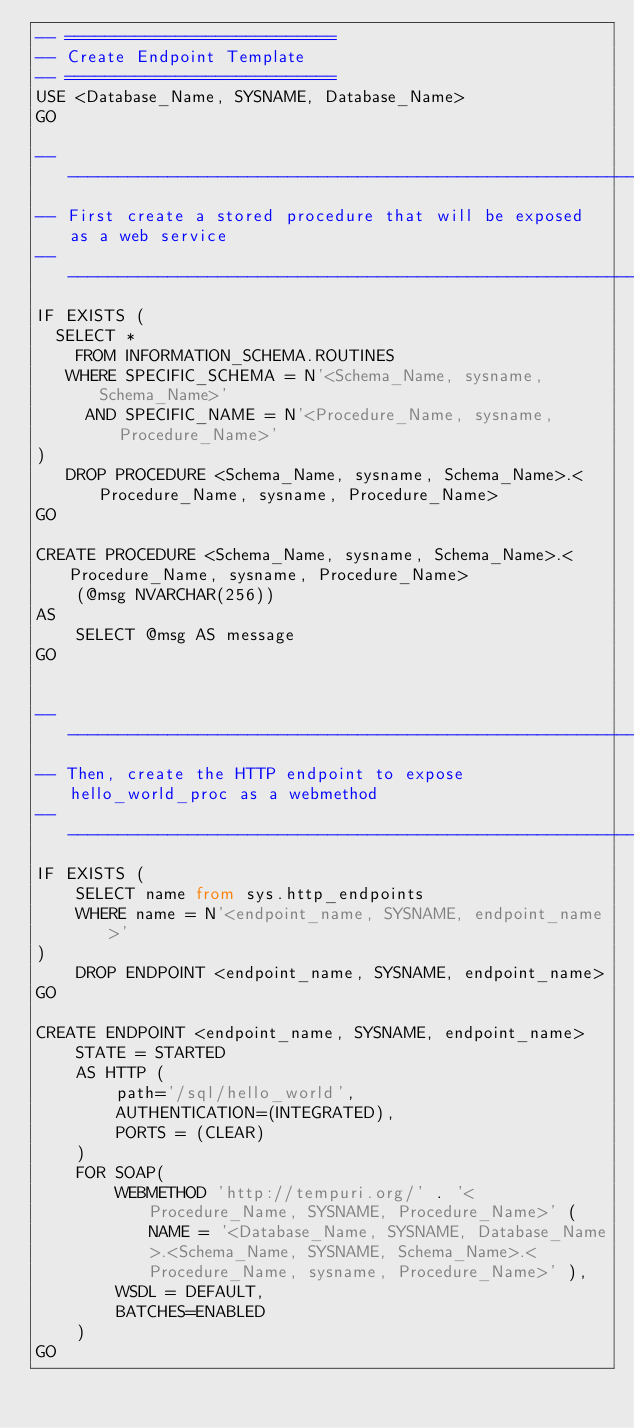<code> <loc_0><loc_0><loc_500><loc_500><_SQL_>-- ===========================
-- Create Endpoint Template
-- ===========================
USE <Database_Name, SYSNAME, Database_Name>
GO

---------------------------------------------------------------------------- 
-- First create a stored procedure that will be exposed as a web service
---------------------------------------------------------------------------- 
IF EXISTS (
  SELECT * 
    FROM INFORMATION_SCHEMA.ROUTINES 
   WHERE SPECIFIC_SCHEMA = N'<Schema_Name, sysname, Schema_Name>'
     AND SPECIFIC_NAME = N'<Procedure_Name, sysname, Procedure_Name>' 
)
   DROP PROCEDURE <Schema_Name, sysname, Schema_Name>.<Procedure_Name, sysname, Procedure_Name>
GO

CREATE PROCEDURE <Schema_Name, sysname, Schema_Name>.<Procedure_Name, sysname, Procedure_Name>
	(@msg NVARCHAR(256))
AS 
	SELECT @msg AS message
GO


---------------------------------------------------------------------------- 
-- Then, create the HTTP endpoint to expose hello_world_proc as a webmethod
---------------------------------------------------------------------------- 
IF EXISTS (
	SELECT name from sys.http_endpoints 
	WHERE name = N'<endpoint_name, SYSNAME, endpoint_name>'
)
	DROP ENDPOINT <endpoint_name, SYSNAME, endpoint_name>
GO

CREATE ENDPOINT <endpoint_name, SYSNAME, endpoint_name>
	STATE = STARTED
	AS HTTP (
		path='/sql/hello_world',
		AUTHENTICATION=(INTEGRATED),
		PORTS = (CLEAR)
	)
	FOR SOAP(
		WEBMETHOD 'http://tempuri.org/' . '<Procedure_Name, SYSNAME, Procedure_Name>' (NAME = '<Database_Name, SYSNAME, Database_Name>.<Schema_Name, SYSNAME, Schema_Name>.<Procedure_Name, sysname, Procedure_Name>' ),
		WSDL = DEFAULT,
		BATCHES=ENABLED
	)
GO

</code> 